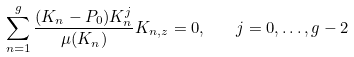Convert formula to latex. <formula><loc_0><loc_0><loc_500><loc_500>\sum _ { n = 1 } ^ { g } \frac { ( K _ { n } - P _ { 0 } ) K _ { n } ^ { j } } { \mu ( K _ { n } ) } K _ { n , z } = 0 , \quad j = 0 , \dots , g - 2</formula> 